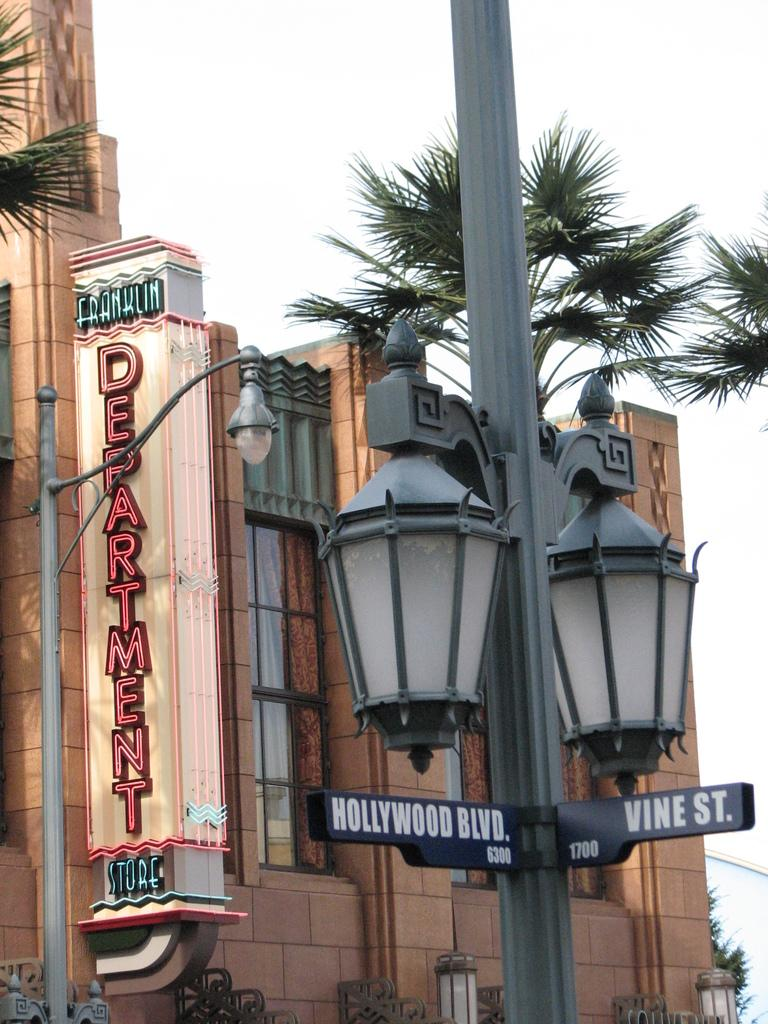Provide a one-sentence caption for the provided image. hollywood blvs street sign and building on display. 